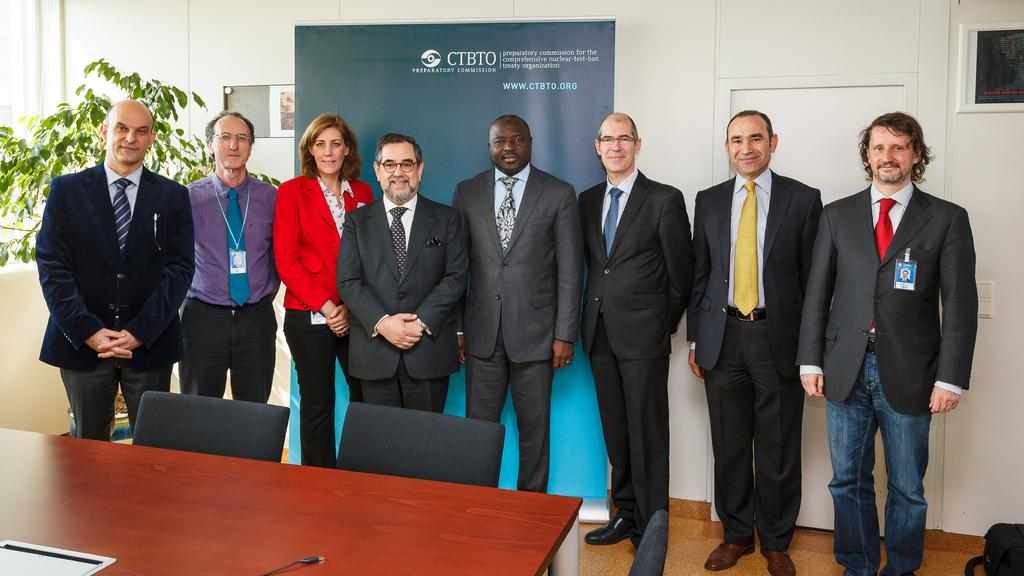What are the people in the image doing? The people in the image are standing next to each other. What furniture is present in the image? There is a table and 2 chairs in the image. What can be seen in the background of the image? There is a plant, a wall, and a banner in the background of the image. What type of key is hanging from the plant in the image? There is no key present in the image, as it only features a plant, a wall, and a banner in the background. 